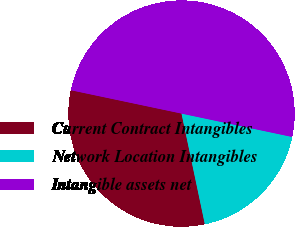Convert chart. <chart><loc_0><loc_0><loc_500><loc_500><pie_chart><fcel>Current Contract Intangibles<fcel>Network Location Intangibles<fcel>Intangible assets net<nl><fcel>31.62%<fcel>18.38%<fcel>50.0%<nl></chart> 